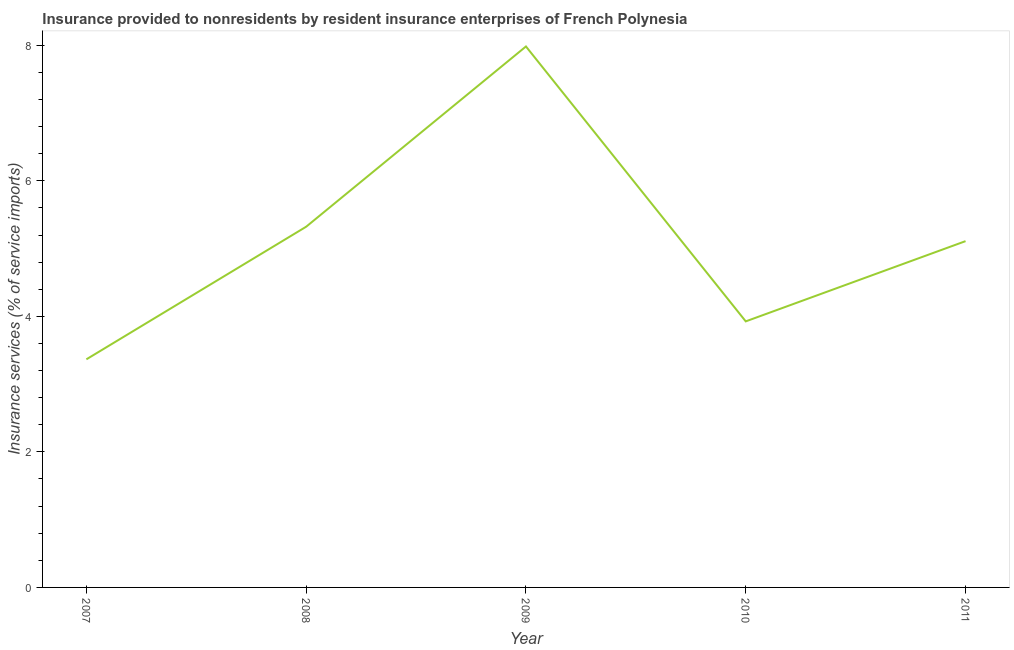What is the insurance and financial services in 2008?
Make the answer very short. 5.32. Across all years, what is the maximum insurance and financial services?
Offer a very short reply. 7.98. Across all years, what is the minimum insurance and financial services?
Offer a very short reply. 3.37. In which year was the insurance and financial services maximum?
Your response must be concise. 2009. What is the sum of the insurance and financial services?
Offer a very short reply. 25.71. What is the difference between the insurance and financial services in 2007 and 2008?
Make the answer very short. -1.96. What is the average insurance and financial services per year?
Your answer should be compact. 5.14. What is the median insurance and financial services?
Your answer should be very brief. 5.11. What is the ratio of the insurance and financial services in 2007 to that in 2008?
Give a very brief answer. 0.63. Is the insurance and financial services in 2010 less than that in 2011?
Your response must be concise. Yes. What is the difference between the highest and the second highest insurance and financial services?
Provide a short and direct response. 2.66. Is the sum of the insurance and financial services in 2008 and 2010 greater than the maximum insurance and financial services across all years?
Provide a succinct answer. Yes. What is the difference between the highest and the lowest insurance and financial services?
Keep it short and to the point. 4.62. How many years are there in the graph?
Keep it short and to the point. 5. What is the difference between two consecutive major ticks on the Y-axis?
Give a very brief answer. 2. Does the graph contain any zero values?
Offer a very short reply. No. Does the graph contain grids?
Your answer should be compact. No. What is the title of the graph?
Keep it short and to the point. Insurance provided to nonresidents by resident insurance enterprises of French Polynesia. What is the label or title of the Y-axis?
Make the answer very short. Insurance services (% of service imports). What is the Insurance services (% of service imports) of 2007?
Keep it short and to the point. 3.37. What is the Insurance services (% of service imports) of 2008?
Provide a succinct answer. 5.32. What is the Insurance services (% of service imports) of 2009?
Offer a very short reply. 7.98. What is the Insurance services (% of service imports) in 2010?
Offer a very short reply. 3.93. What is the Insurance services (% of service imports) of 2011?
Provide a short and direct response. 5.11. What is the difference between the Insurance services (% of service imports) in 2007 and 2008?
Your answer should be very brief. -1.96. What is the difference between the Insurance services (% of service imports) in 2007 and 2009?
Ensure brevity in your answer.  -4.62. What is the difference between the Insurance services (% of service imports) in 2007 and 2010?
Your response must be concise. -0.56. What is the difference between the Insurance services (% of service imports) in 2007 and 2011?
Provide a succinct answer. -1.74. What is the difference between the Insurance services (% of service imports) in 2008 and 2009?
Your response must be concise. -2.66. What is the difference between the Insurance services (% of service imports) in 2008 and 2010?
Ensure brevity in your answer.  1.4. What is the difference between the Insurance services (% of service imports) in 2008 and 2011?
Provide a short and direct response. 0.21. What is the difference between the Insurance services (% of service imports) in 2009 and 2010?
Give a very brief answer. 4.06. What is the difference between the Insurance services (% of service imports) in 2009 and 2011?
Offer a terse response. 2.87. What is the difference between the Insurance services (% of service imports) in 2010 and 2011?
Give a very brief answer. -1.18. What is the ratio of the Insurance services (% of service imports) in 2007 to that in 2008?
Provide a short and direct response. 0.63. What is the ratio of the Insurance services (% of service imports) in 2007 to that in 2009?
Your answer should be very brief. 0.42. What is the ratio of the Insurance services (% of service imports) in 2007 to that in 2010?
Ensure brevity in your answer.  0.86. What is the ratio of the Insurance services (% of service imports) in 2007 to that in 2011?
Provide a short and direct response. 0.66. What is the ratio of the Insurance services (% of service imports) in 2008 to that in 2009?
Ensure brevity in your answer.  0.67. What is the ratio of the Insurance services (% of service imports) in 2008 to that in 2010?
Provide a succinct answer. 1.36. What is the ratio of the Insurance services (% of service imports) in 2008 to that in 2011?
Make the answer very short. 1.04. What is the ratio of the Insurance services (% of service imports) in 2009 to that in 2010?
Offer a terse response. 2.03. What is the ratio of the Insurance services (% of service imports) in 2009 to that in 2011?
Your response must be concise. 1.56. What is the ratio of the Insurance services (% of service imports) in 2010 to that in 2011?
Ensure brevity in your answer.  0.77. 